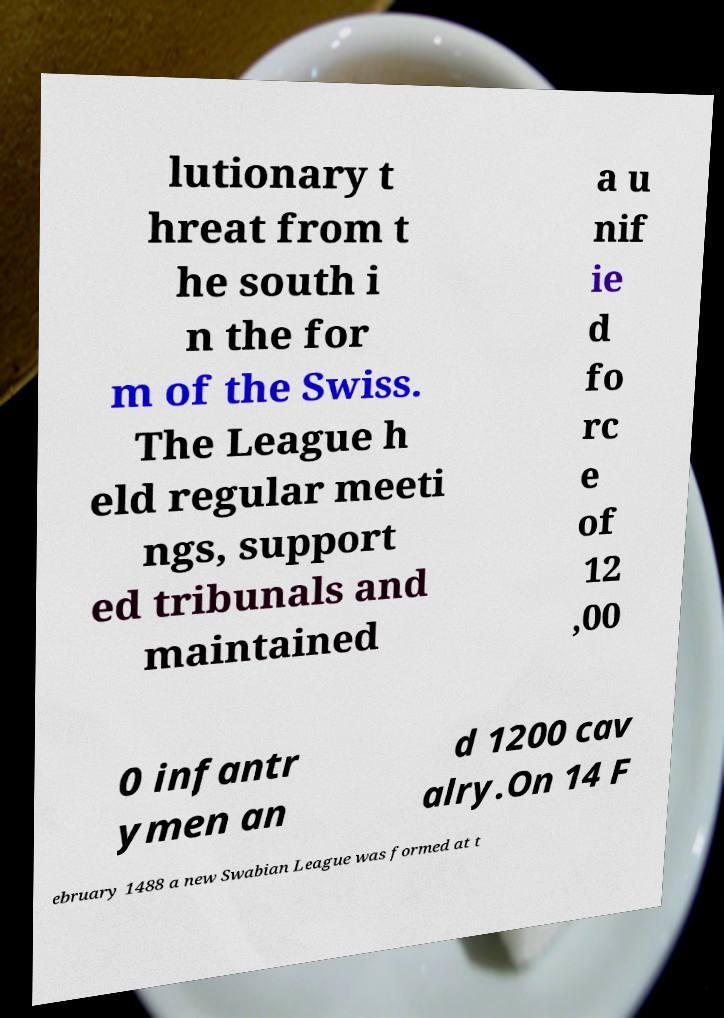For documentation purposes, I need the text within this image transcribed. Could you provide that? lutionary t hreat from t he south i n the for m of the Swiss. The League h eld regular meeti ngs, support ed tribunals and maintained a u nif ie d fo rc e of 12 ,00 0 infantr ymen an d 1200 cav alry.On 14 F ebruary 1488 a new Swabian League was formed at t 